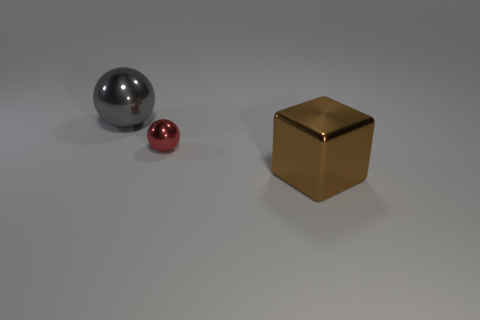Add 3 small yellow rubber things. How many objects exist? 6 Subtract 1 cubes. How many cubes are left? 0 Subtract all cubes. How many objects are left? 2 Add 1 small balls. How many small balls exist? 2 Subtract 0 purple balls. How many objects are left? 3 Subtract all cyan balls. Subtract all yellow cylinders. How many balls are left? 2 Subtract all green cylinders. How many gray balls are left? 1 Subtract all big brown things. Subtract all large cubes. How many objects are left? 1 Add 2 gray metal spheres. How many gray metal spheres are left? 3 